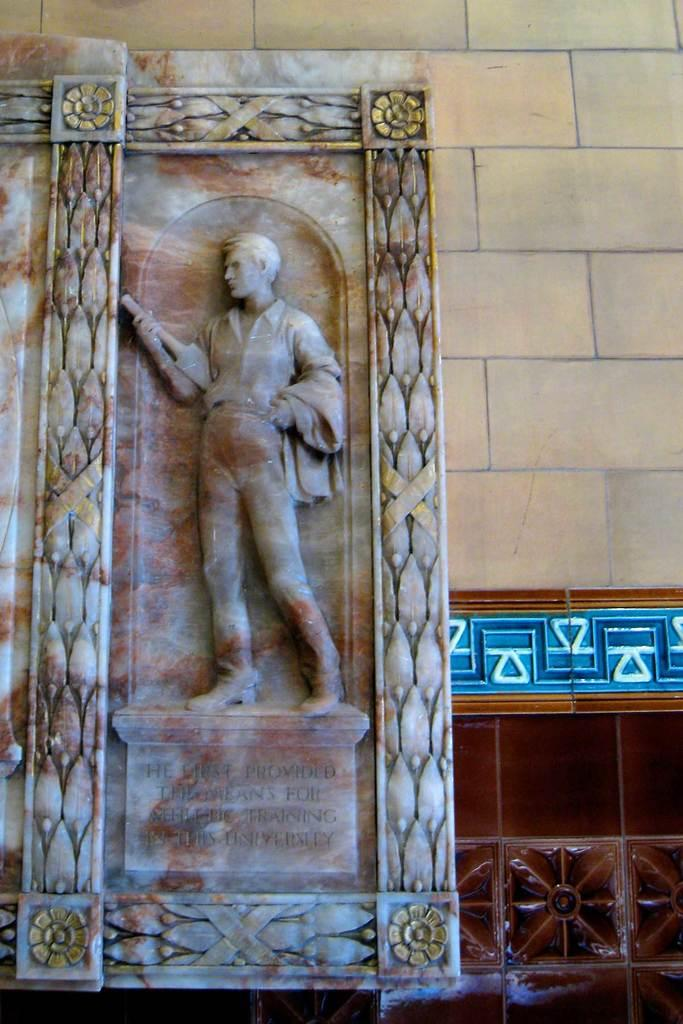What is the main subject on the wall in the image? There is a sculpture on a wall in the image. What else can be seen on the walls in the image? There are decorations on the walls in the image. What type of wall can be seen in the background of the image? There is a wall with bricks in the background of the image. What type of payment is being made in the image? There is no payment being made in the image; it features a sculpture and decorations on walls. What time of day is depicted in the image? The time of day is not specified in the image; it only shows a sculpture, decorations, and walls. 